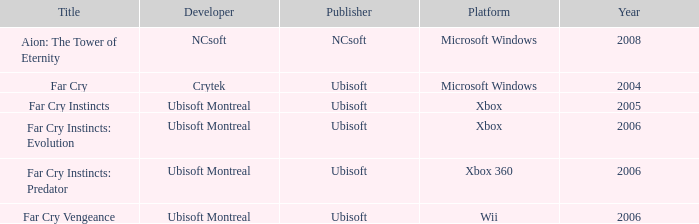Which publisher has Far Cry as the title? Ubisoft. 